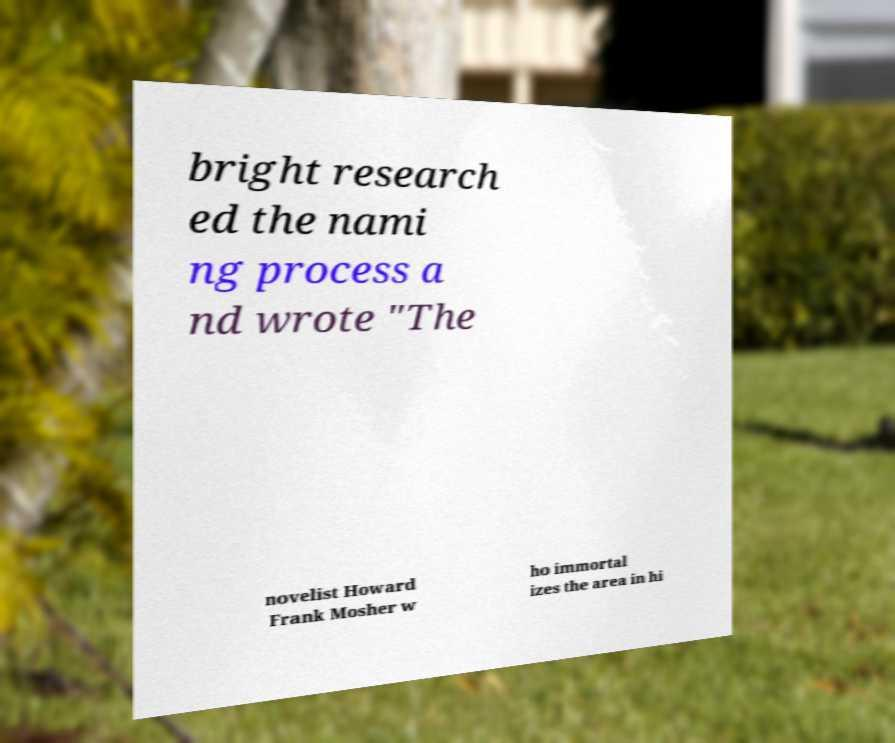What messages or text are displayed in this image? I need them in a readable, typed format. bright research ed the nami ng process a nd wrote "The novelist Howard Frank Mosher w ho immortal izes the area in hi 